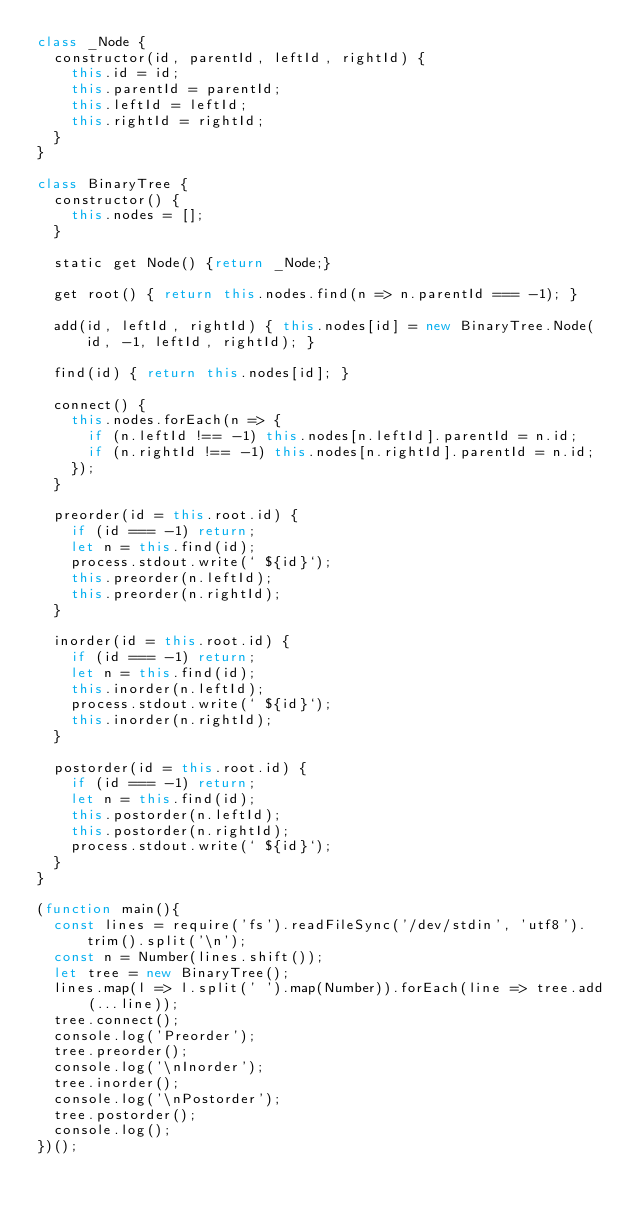Convert code to text. <code><loc_0><loc_0><loc_500><loc_500><_JavaScript_>class _Node {
  constructor(id, parentId, leftId, rightId) {
    this.id = id;
    this.parentId = parentId;
    this.leftId = leftId;
    this.rightId = rightId;
  }
}

class BinaryTree {
  constructor() {
    this.nodes = [];
  }

  static get Node() {return _Node;}

  get root() { return this.nodes.find(n => n.parentId === -1); }

  add(id, leftId, rightId) { this.nodes[id] = new BinaryTree.Node(id, -1, leftId, rightId); }

  find(id) { return this.nodes[id]; }

  connect() {
    this.nodes.forEach(n => {
      if (n.leftId !== -1) this.nodes[n.leftId].parentId = n.id;
      if (n.rightId !== -1) this.nodes[n.rightId].parentId = n.id;
    });
  }

  preorder(id = this.root.id) {
    if (id === -1) return;
    let n = this.find(id);
    process.stdout.write(` ${id}`);
    this.preorder(n.leftId);
    this.preorder(n.rightId);
  }

  inorder(id = this.root.id) {
    if (id === -1) return;
    let n = this.find(id);
    this.inorder(n.leftId);
    process.stdout.write(` ${id}`);
    this.inorder(n.rightId);
  }

  postorder(id = this.root.id) {
    if (id === -1) return;
    let n = this.find(id);
    this.postorder(n.leftId);
    this.postorder(n.rightId);
    process.stdout.write(` ${id}`);
  }
}

(function main(){
  const lines = require('fs').readFileSync('/dev/stdin', 'utf8').trim().split('\n');
  const n = Number(lines.shift());
  let tree = new BinaryTree();
  lines.map(l => l.split(' ').map(Number)).forEach(line => tree.add(...line));
  tree.connect();
  console.log('Preorder');
  tree.preorder();
  console.log('\nInorder');
  tree.inorder();
  console.log('\nPostorder');
  tree.postorder();
  console.log();
})();

</code> 